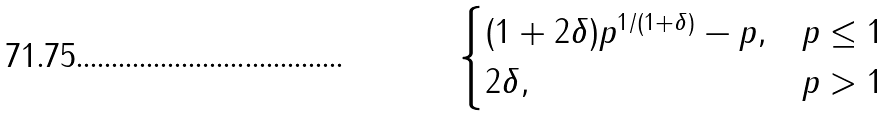Convert formula to latex. <formula><loc_0><loc_0><loc_500><loc_500>\begin{cases} ( 1 + 2 \delta ) p ^ { 1 / ( 1 + \delta ) } - p , & p \leq 1 \\ 2 \delta , & p > 1 \end{cases}</formula> 